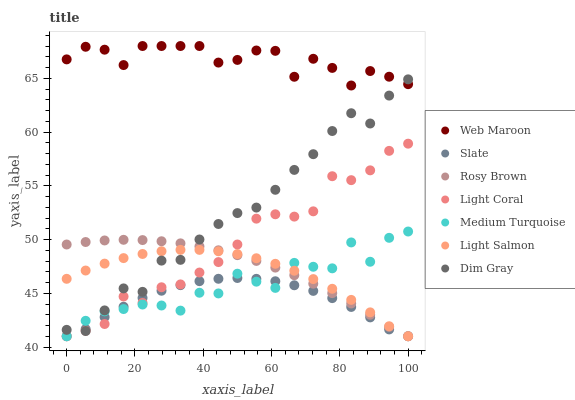Does Slate have the minimum area under the curve?
Answer yes or no. Yes. Does Web Maroon have the maximum area under the curve?
Answer yes or no. Yes. Does Dim Gray have the minimum area under the curve?
Answer yes or no. No. Does Dim Gray have the maximum area under the curve?
Answer yes or no. No. Is Rosy Brown the smoothest?
Answer yes or no. Yes. Is Medium Turquoise the roughest?
Answer yes or no. Yes. Is Dim Gray the smoothest?
Answer yes or no. No. Is Dim Gray the roughest?
Answer yes or no. No. Does Light Salmon have the lowest value?
Answer yes or no. Yes. Does Dim Gray have the lowest value?
Answer yes or no. No. Does Web Maroon have the highest value?
Answer yes or no. Yes. Does Dim Gray have the highest value?
Answer yes or no. No. Is Medium Turquoise less than Web Maroon?
Answer yes or no. Yes. Is Web Maroon greater than Light Coral?
Answer yes or no. Yes. Does Light Coral intersect Rosy Brown?
Answer yes or no. Yes. Is Light Coral less than Rosy Brown?
Answer yes or no. No. Is Light Coral greater than Rosy Brown?
Answer yes or no. No. Does Medium Turquoise intersect Web Maroon?
Answer yes or no. No. 